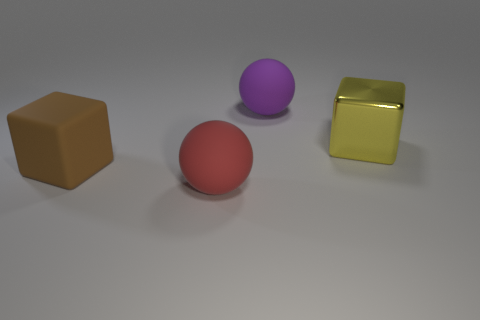Add 3 red shiny objects. How many objects exist? 7 Subtract all green metallic cubes. Subtract all large purple balls. How many objects are left? 3 Add 2 large red matte objects. How many large red matte objects are left? 3 Add 4 green metallic blocks. How many green metallic blocks exist? 4 Subtract 0 green blocks. How many objects are left? 4 